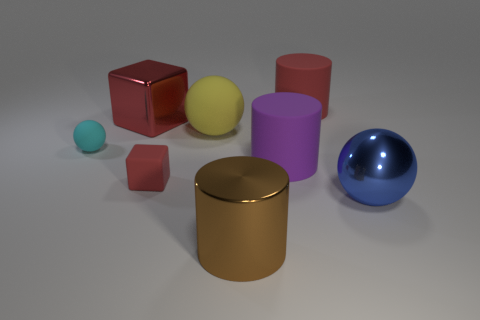Add 1 big blue spheres. How many objects exist? 9 Subtract all cubes. How many objects are left? 6 Subtract 0 yellow blocks. How many objects are left? 8 Subtract all big rubber blocks. Subtract all tiny balls. How many objects are left? 7 Add 6 spheres. How many spheres are left? 9 Add 8 cyan rubber spheres. How many cyan rubber spheres exist? 9 